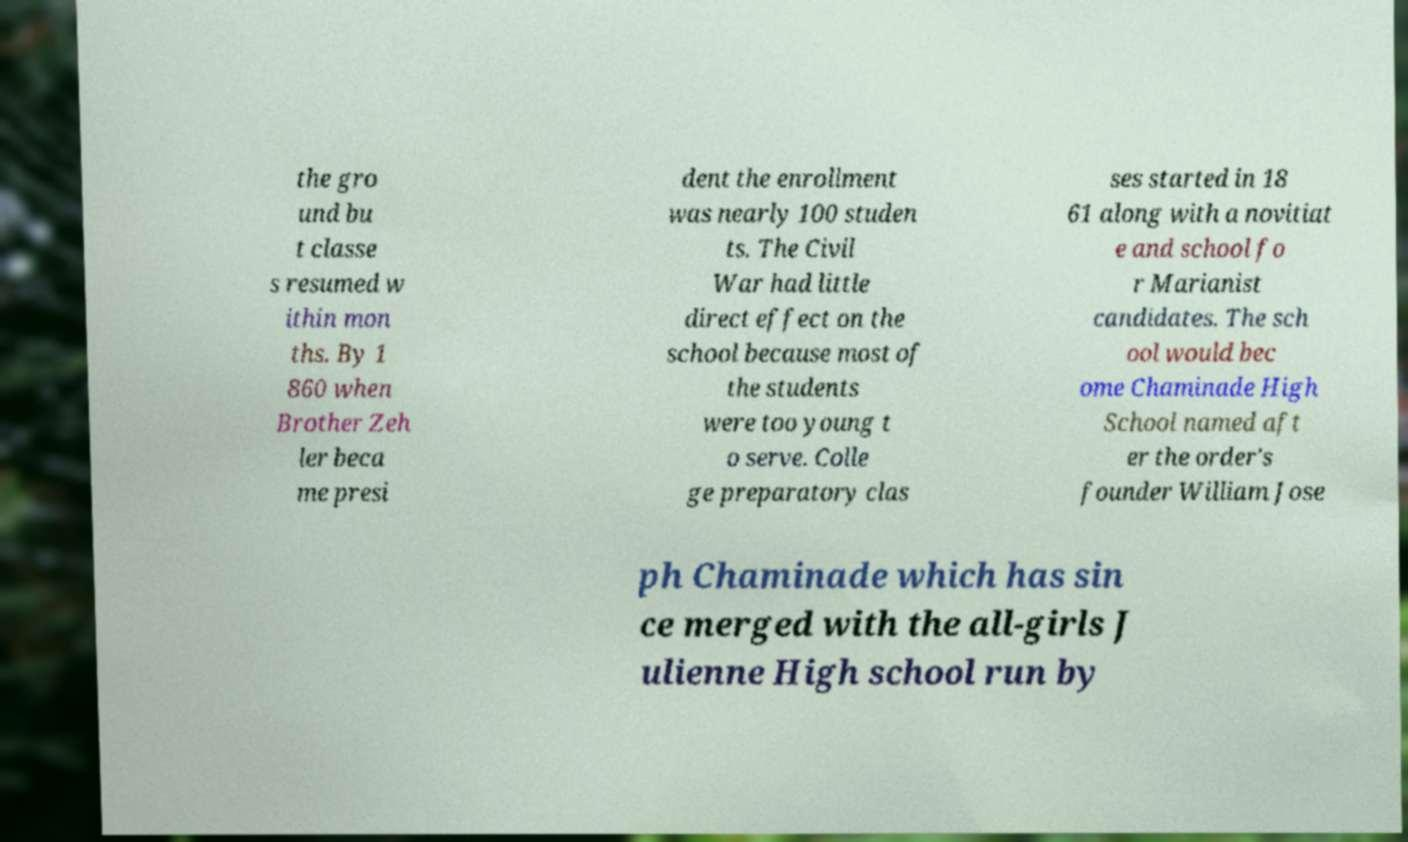Can you accurately transcribe the text from the provided image for me? the gro und bu t classe s resumed w ithin mon ths. By 1 860 when Brother Zeh ler beca me presi dent the enrollment was nearly 100 studen ts. The Civil War had little direct effect on the school because most of the students were too young t o serve. Colle ge preparatory clas ses started in 18 61 along with a novitiat e and school fo r Marianist candidates. The sch ool would bec ome Chaminade High School named aft er the order's founder William Jose ph Chaminade which has sin ce merged with the all-girls J ulienne High school run by 